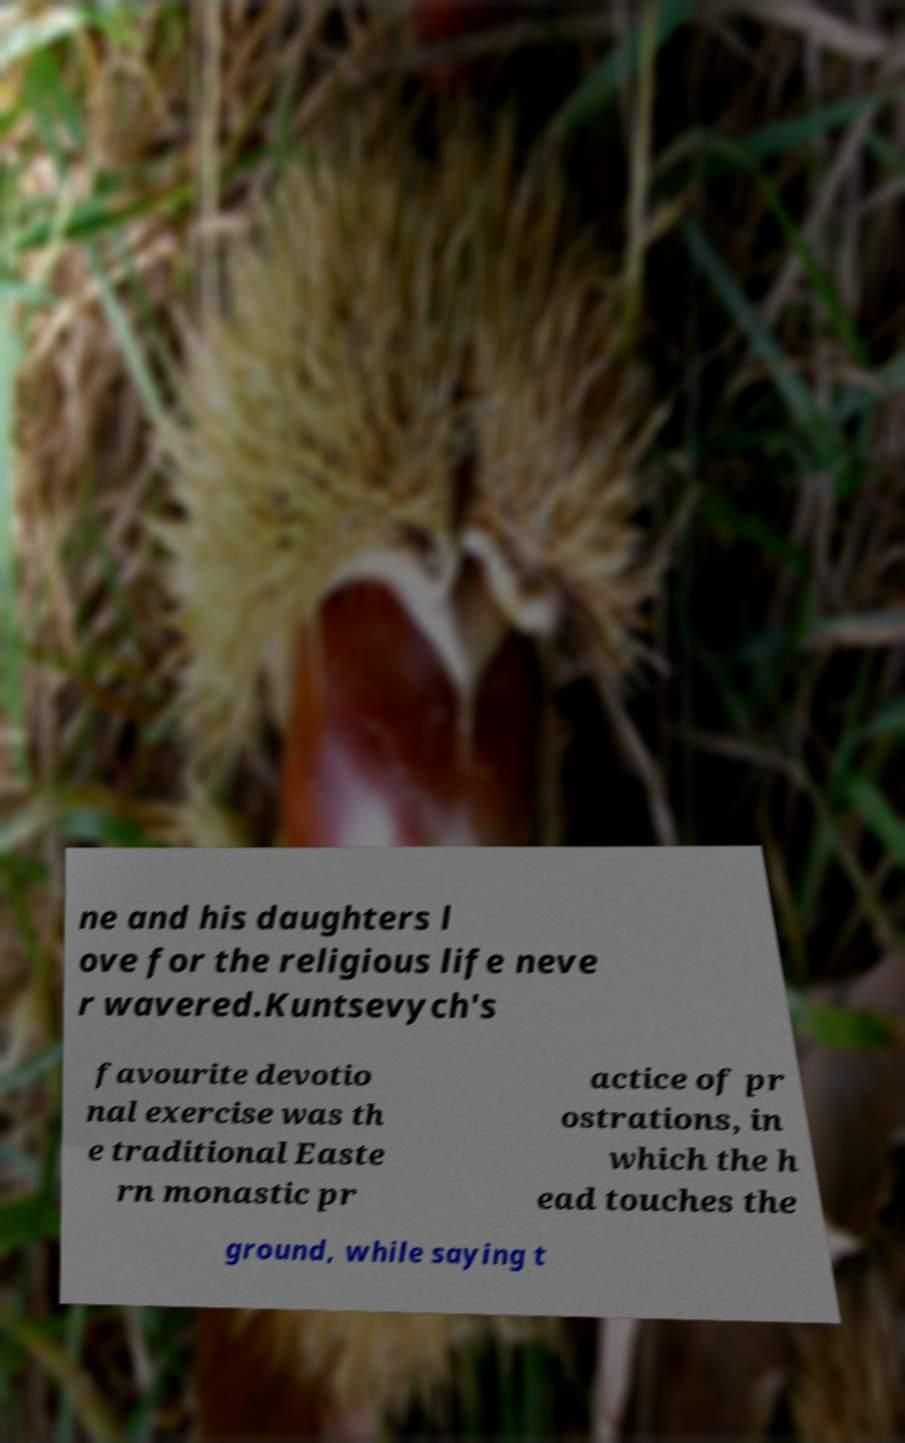I need the written content from this picture converted into text. Can you do that? ne and his daughters l ove for the religious life neve r wavered.Kuntsevych's favourite devotio nal exercise was th e traditional Easte rn monastic pr actice of pr ostrations, in which the h ead touches the ground, while saying t 